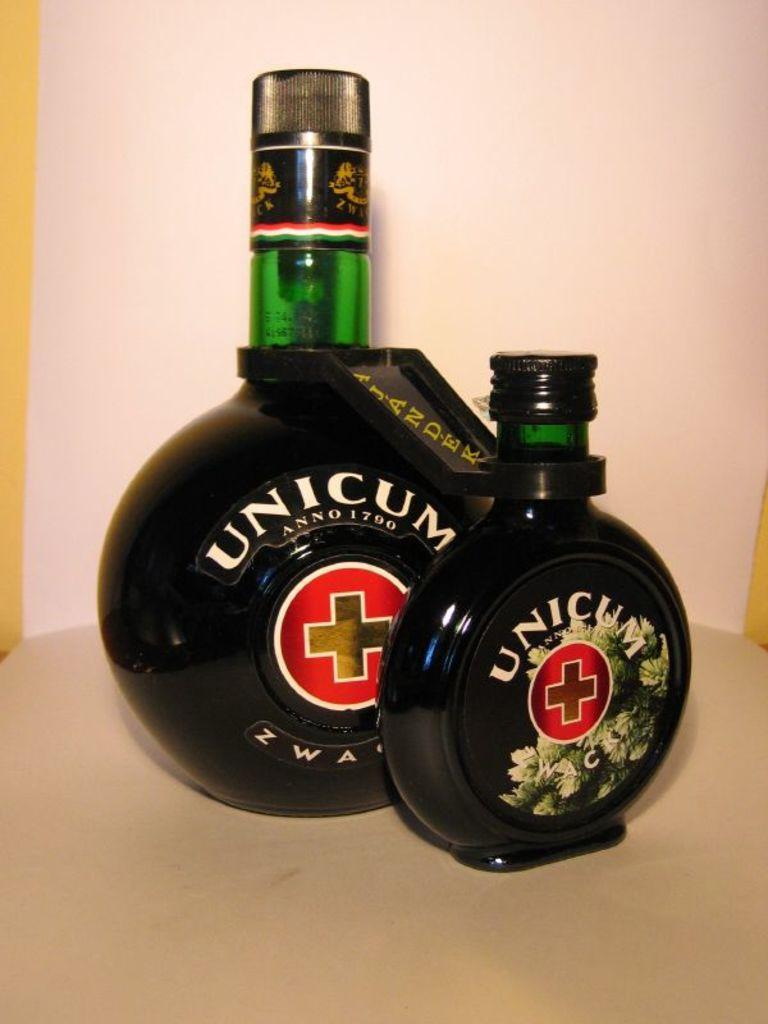What objects are present in the image? There are bottles in the image. Can you describe the bottles in the image? Unfortunately, the provided facts do not give any details about the bottles, so we cannot describe them further. What language is spoken by the iron in the image? There is no iron present in the image, and therefore it cannot speak any language. 